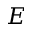<formula> <loc_0><loc_0><loc_500><loc_500>E</formula> 